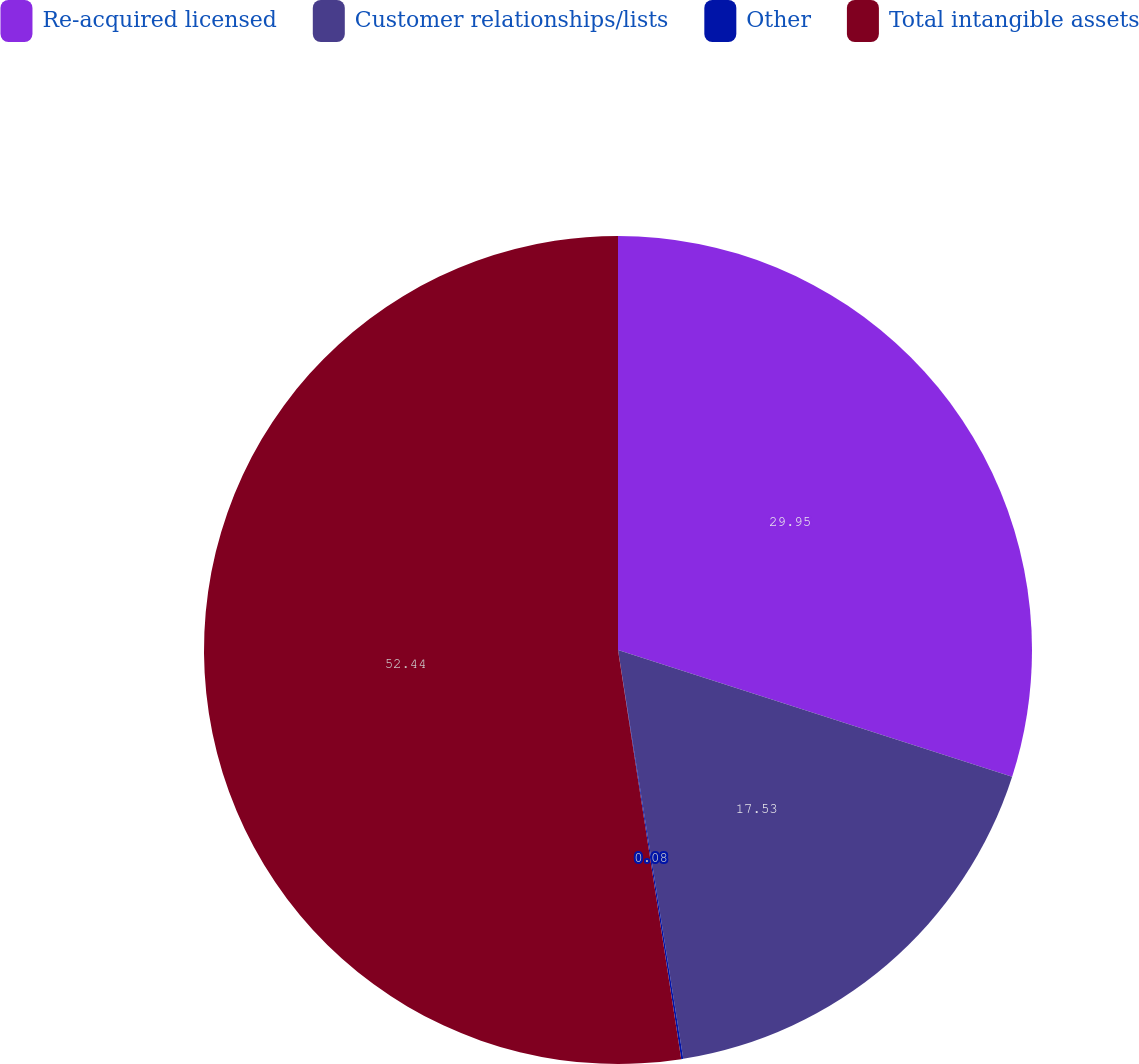Convert chart. <chart><loc_0><loc_0><loc_500><loc_500><pie_chart><fcel>Re-acquired licensed<fcel>Customer relationships/lists<fcel>Other<fcel>Total intangible assets<nl><fcel>29.95%<fcel>17.53%<fcel>0.08%<fcel>52.44%<nl></chart> 